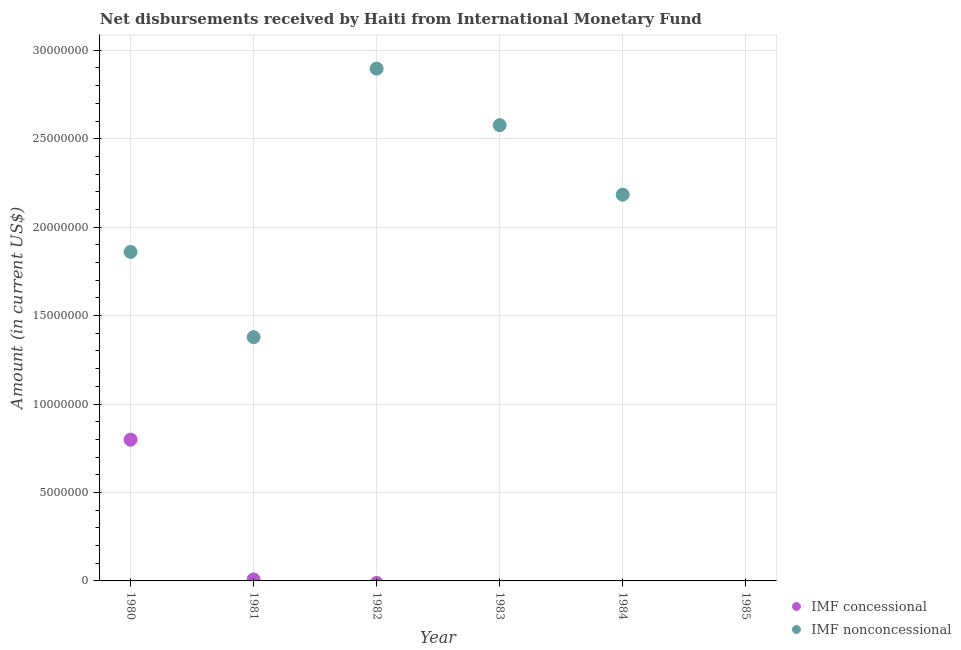What is the net concessional disbursements from imf in 1981?
Give a very brief answer. 8.70e+04. Across all years, what is the maximum net non concessional disbursements from imf?
Your answer should be compact. 2.90e+07. In which year was the net non concessional disbursements from imf maximum?
Give a very brief answer. 1982. What is the total net non concessional disbursements from imf in the graph?
Make the answer very short. 1.09e+08. What is the difference between the net concessional disbursements from imf in 1980 and that in 1981?
Offer a very short reply. 7.90e+06. What is the difference between the net non concessional disbursements from imf in 1985 and the net concessional disbursements from imf in 1980?
Make the answer very short. -7.99e+06. What is the average net non concessional disbursements from imf per year?
Offer a terse response. 1.82e+07. In the year 1980, what is the difference between the net concessional disbursements from imf and net non concessional disbursements from imf?
Offer a very short reply. -1.06e+07. What is the ratio of the net non concessional disbursements from imf in 1982 to that in 1984?
Keep it short and to the point. 1.33. Is the net non concessional disbursements from imf in 1981 less than that in 1984?
Provide a succinct answer. Yes. What is the difference between the highest and the second highest net non concessional disbursements from imf?
Offer a very short reply. 3.20e+06. What is the difference between the highest and the lowest net concessional disbursements from imf?
Make the answer very short. 7.99e+06. Is the sum of the net non concessional disbursements from imf in 1980 and 1982 greater than the maximum net concessional disbursements from imf across all years?
Offer a very short reply. Yes. Is the net non concessional disbursements from imf strictly greater than the net concessional disbursements from imf over the years?
Provide a short and direct response. No. Is the net non concessional disbursements from imf strictly less than the net concessional disbursements from imf over the years?
Your answer should be very brief. No. How many dotlines are there?
Your answer should be very brief. 2. Does the graph contain any zero values?
Ensure brevity in your answer.  Yes. Does the graph contain grids?
Provide a succinct answer. Yes. Where does the legend appear in the graph?
Ensure brevity in your answer.  Bottom right. How many legend labels are there?
Ensure brevity in your answer.  2. What is the title of the graph?
Ensure brevity in your answer.  Net disbursements received by Haiti from International Monetary Fund. What is the label or title of the X-axis?
Provide a succinct answer. Year. What is the label or title of the Y-axis?
Give a very brief answer. Amount (in current US$). What is the Amount (in current US$) of IMF concessional in 1980?
Ensure brevity in your answer.  7.99e+06. What is the Amount (in current US$) of IMF nonconcessional in 1980?
Your response must be concise. 1.86e+07. What is the Amount (in current US$) in IMF concessional in 1981?
Provide a succinct answer. 8.70e+04. What is the Amount (in current US$) of IMF nonconcessional in 1981?
Your response must be concise. 1.38e+07. What is the Amount (in current US$) in IMF nonconcessional in 1982?
Ensure brevity in your answer.  2.90e+07. What is the Amount (in current US$) of IMF concessional in 1983?
Provide a succinct answer. 0. What is the Amount (in current US$) in IMF nonconcessional in 1983?
Provide a succinct answer. 2.58e+07. What is the Amount (in current US$) of IMF concessional in 1984?
Keep it short and to the point. 0. What is the Amount (in current US$) in IMF nonconcessional in 1984?
Give a very brief answer. 2.18e+07. What is the Amount (in current US$) in IMF concessional in 1985?
Your answer should be very brief. 0. What is the Amount (in current US$) in IMF nonconcessional in 1985?
Give a very brief answer. 0. Across all years, what is the maximum Amount (in current US$) of IMF concessional?
Offer a terse response. 7.99e+06. Across all years, what is the maximum Amount (in current US$) of IMF nonconcessional?
Your answer should be very brief. 2.90e+07. Across all years, what is the minimum Amount (in current US$) of IMF concessional?
Ensure brevity in your answer.  0. Across all years, what is the minimum Amount (in current US$) in IMF nonconcessional?
Your answer should be compact. 0. What is the total Amount (in current US$) of IMF concessional in the graph?
Give a very brief answer. 8.07e+06. What is the total Amount (in current US$) of IMF nonconcessional in the graph?
Offer a very short reply. 1.09e+08. What is the difference between the Amount (in current US$) of IMF concessional in 1980 and that in 1981?
Give a very brief answer. 7.90e+06. What is the difference between the Amount (in current US$) in IMF nonconcessional in 1980 and that in 1981?
Provide a succinct answer. 4.82e+06. What is the difference between the Amount (in current US$) of IMF nonconcessional in 1980 and that in 1982?
Offer a very short reply. -1.04e+07. What is the difference between the Amount (in current US$) of IMF nonconcessional in 1980 and that in 1983?
Give a very brief answer. -7.17e+06. What is the difference between the Amount (in current US$) of IMF nonconcessional in 1980 and that in 1984?
Give a very brief answer. -3.24e+06. What is the difference between the Amount (in current US$) of IMF nonconcessional in 1981 and that in 1982?
Make the answer very short. -1.52e+07. What is the difference between the Amount (in current US$) in IMF nonconcessional in 1981 and that in 1983?
Provide a short and direct response. -1.20e+07. What is the difference between the Amount (in current US$) of IMF nonconcessional in 1981 and that in 1984?
Provide a short and direct response. -8.05e+06. What is the difference between the Amount (in current US$) of IMF nonconcessional in 1982 and that in 1983?
Offer a very short reply. 3.20e+06. What is the difference between the Amount (in current US$) in IMF nonconcessional in 1982 and that in 1984?
Keep it short and to the point. 7.13e+06. What is the difference between the Amount (in current US$) of IMF nonconcessional in 1983 and that in 1984?
Provide a succinct answer. 3.93e+06. What is the difference between the Amount (in current US$) in IMF concessional in 1980 and the Amount (in current US$) in IMF nonconcessional in 1981?
Keep it short and to the point. -5.79e+06. What is the difference between the Amount (in current US$) of IMF concessional in 1980 and the Amount (in current US$) of IMF nonconcessional in 1982?
Provide a succinct answer. -2.10e+07. What is the difference between the Amount (in current US$) in IMF concessional in 1980 and the Amount (in current US$) in IMF nonconcessional in 1983?
Provide a succinct answer. -1.78e+07. What is the difference between the Amount (in current US$) of IMF concessional in 1980 and the Amount (in current US$) of IMF nonconcessional in 1984?
Keep it short and to the point. -1.38e+07. What is the difference between the Amount (in current US$) in IMF concessional in 1981 and the Amount (in current US$) in IMF nonconcessional in 1982?
Provide a short and direct response. -2.89e+07. What is the difference between the Amount (in current US$) in IMF concessional in 1981 and the Amount (in current US$) in IMF nonconcessional in 1983?
Your answer should be compact. -2.57e+07. What is the difference between the Amount (in current US$) of IMF concessional in 1981 and the Amount (in current US$) of IMF nonconcessional in 1984?
Provide a succinct answer. -2.17e+07. What is the average Amount (in current US$) of IMF concessional per year?
Offer a very short reply. 1.35e+06. What is the average Amount (in current US$) in IMF nonconcessional per year?
Provide a succinct answer. 1.82e+07. In the year 1980, what is the difference between the Amount (in current US$) in IMF concessional and Amount (in current US$) in IMF nonconcessional?
Ensure brevity in your answer.  -1.06e+07. In the year 1981, what is the difference between the Amount (in current US$) in IMF concessional and Amount (in current US$) in IMF nonconcessional?
Offer a very short reply. -1.37e+07. What is the ratio of the Amount (in current US$) of IMF concessional in 1980 to that in 1981?
Ensure brevity in your answer.  91.8. What is the ratio of the Amount (in current US$) in IMF nonconcessional in 1980 to that in 1981?
Your response must be concise. 1.35. What is the ratio of the Amount (in current US$) of IMF nonconcessional in 1980 to that in 1982?
Make the answer very short. 0.64. What is the ratio of the Amount (in current US$) of IMF nonconcessional in 1980 to that in 1983?
Offer a terse response. 0.72. What is the ratio of the Amount (in current US$) of IMF nonconcessional in 1980 to that in 1984?
Make the answer very short. 0.85. What is the ratio of the Amount (in current US$) in IMF nonconcessional in 1981 to that in 1982?
Your response must be concise. 0.48. What is the ratio of the Amount (in current US$) in IMF nonconcessional in 1981 to that in 1983?
Offer a very short reply. 0.53. What is the ratio of the Amount (in current US$) of IMF nonconcessional in 1981 to that in 1984?
Offer a terse response. 0.63. What is the ratio of the Amount (in current US$) in IMF nonconcessional in 1982 to that in 1983?
Give a very brief answer. 1.12. What is the ratio of the Amount (in current US$) in IMF nonconcessional in 1982 to that in 1984?
Offer a terse response. 1.33. What is the ratio of the Amount (in current US$) in IMF nonconcessional in 1983 to that in 1984?
Ensure brevity in your answer.  1.18. What is the difference between the highest and the second highest Amount (in current US$) in IMF nonconcessional?
Ensure brevity in your answer.  3.20e+06. What is the difference between the highest and the lowest Amount (in current US$) in IMF concessional?
Provide a succinct answer. 7.99e+06. What is the difference between the highest and the lowest Amount (in current US$) in IMF nonconcessional?
Provide a short and direct response. 2.90e+07. 